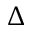<formula> <loc_0><loc_0><loc_500><loc_500>\Delta</formula> 